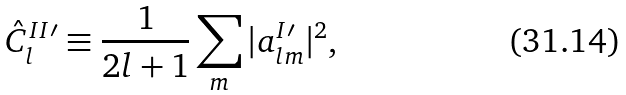<formula> <loc_0><loc_0><loc_500><loc_500>\hat { C } ^ { I I \prime } _ { l } \equiv \frac { 1 } { 2 l + 1 } \sum _ { m } | a ^ { I \prime } _ { l m } | ^ { 2 } ,</formula> 